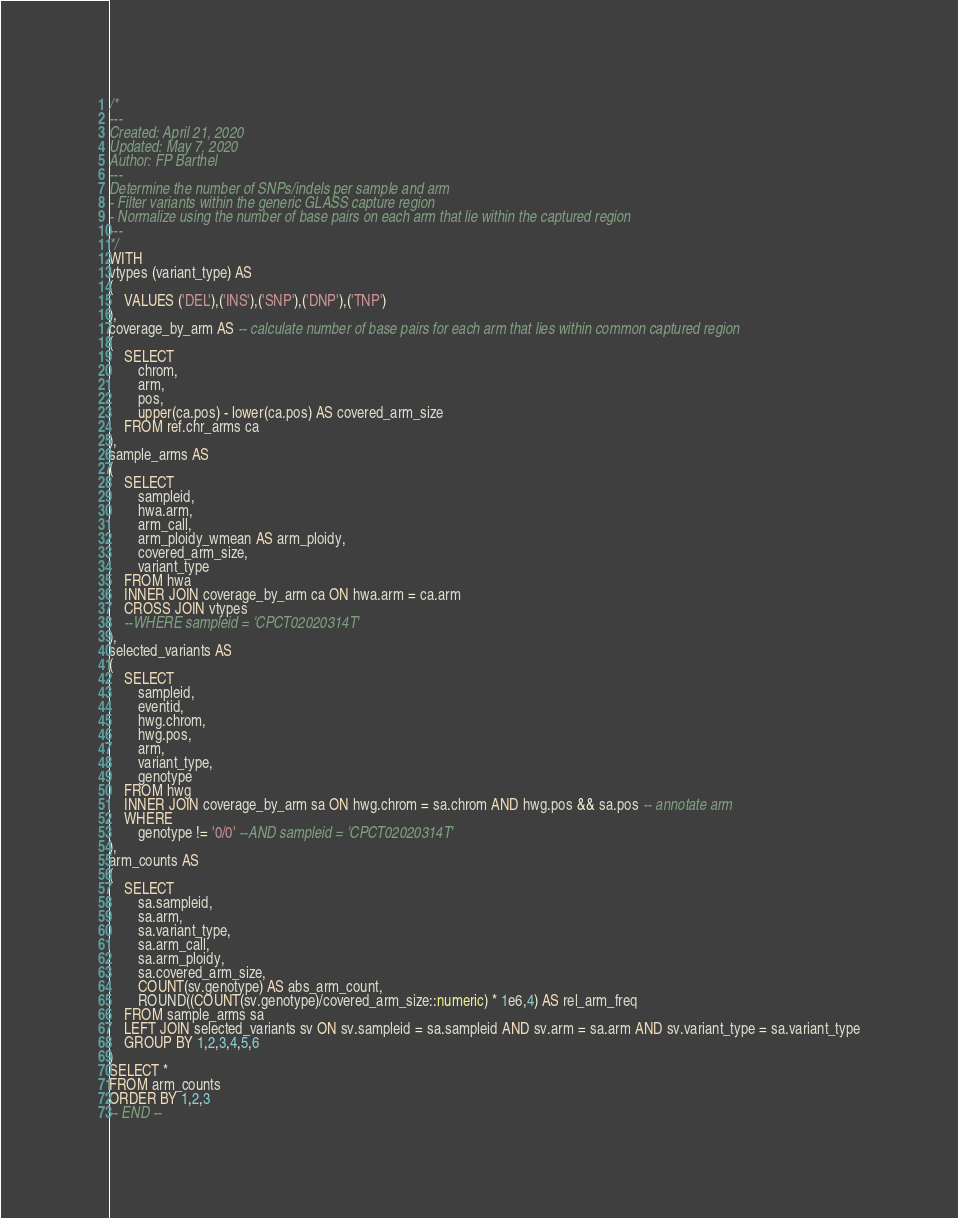Convert code to text. <code><loc_0><loc_0><loc_500><loc_500><_SQL_>/*
---
Created: April 21, 2020
Updated: May 7, 2020
Author: FP Barthel
---
Determine the number of SNPs/indels per sample and arm
- Filter variants within the generic GLASS capture region
- Normalize using the number of base pairs on each arm that lie within the captured region
---
*/
WITH
vtypes (variant_type) AS
(
	VALUES ('DEL'),('INS'),('SNP'),('DNP'),('TNP')
),
coverage_by_arm AS -- calculate number of base pairs for each arm that lies within common captured region
(
	SELECT
		chrom,
		arm,
		pos,
		upper(ca.pos) - lower(ca.pos) AS covered_arm_size
	FROM ref.chr_arms ca
),
sample_arms AS
(
	SELECT
		sampleid,
		hwa.arm,
		arm_call,
		arm_ploidy_wmean AS arm_ploidy,
		covered_arm_size,
		variant_type
	FROM hwa
	INNER JOIN coverage_by_arm ca ON hwa.arm = ca.arm
	CROSS JOIN vtypes
	--WHERE sampleid = 'CPCT02020314T'
),
selected_variants AS
(	
	SELECT
		sampleid,
		eventid,
		hwg.chrom,
		hwg.pos,
		arm,
		variant_type,
		genotype
	FROM hwg
	INNER JOIN coverage_by_arm sa ON hwg.chrom = sa.chrom AND hwg.pos && sa.pos -- annotate arm
	WHERE
		genotype != '0/0' --AND sampleid = 'CPCT02020314T'
),
arm_counts AS
(
	SELECT
		sa.sampleid,
		sa.arm,
		sa.variant_type,
		sa.arm_call,
		sa.arm_ploidy,
		sa.covered_arm_size,
		COUNT(sv.genotype) AS abs_arm_count,
		ROUND((COUNT(sv.genotype)/covered_arm_size::numeric) * 1e6,4) AS rel_arm_freq
	FROM sample_arms sa
	LEFT JOIN selected_variants sv ON sv.sampleid = sa.sampleid AND sv.arm = sa.arm AND sv.variant_type = sa.variant_type
	GROUP BY 1,2,3,4,5,6
)
SELECT *
FROM arm_counts
ORDER BY 1,2,3
-- END --</code> 